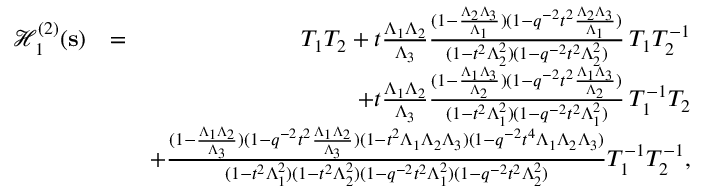<formula> <loc_0><loc_0><loc_500><loc_500>\begin{array} { r l r } { \mathcal { H } _ { 1 } ^ { ( 2 ) } ( \mathbf s ) } & { = } & { T _ { 1 } T _ { 2 } + t \frac { \Lambda _ { 1 } \Lambda _ { 2 } } { \Lambda _ { 3 } } \frac { ( 1 - \frac { \Lambda _ { 2 } \Lambda _ { 3 } } { \Lambda _ { 1 } } ) ( 1 - q ^ { - 2 } t ^ { 2 } \frac { \Lambda _ { 2 } \Lambda _ { 3 } } { \Lambda _ { 1 } } ) } { ( 1 - t ^ { 2 } \Lambda _ { 2 } ^ { 2 } ) ( 1 - q ^ { - 2 } t ^ { 2 } \Lambda _ { 2 } ^ { 2 } ) } \, T _ { 1 } T _ { 2 } ^ { - 1 } } \\ & { + t \frac { \Lambda _ { 1 } \Lambda _ { 2 } } { \Lambda _ { 3 } } \frac { ( 1 - \frac { \Lambda _ { 1 } \Lambda _ { 3 } } { \Lambda _ { 2 } } ) ( 1 - q ^ { - 2 } t ^ { 2 } \frac { \Lambda _ { 1 } \Lambda _ { 3 } } { \Lambda _ { 2 } } ) } { ( 1 - t ^ { 2 } \Lambda _ { 1 } ^ { 2 } ) ( 1 - q ^ { - 2 } t ^ { 2 } \Lambda _ { 1 } ^ { 2 } ) } \, T _ { 1 } ^ { - 1 } T _ { 2 } } \\ & { + \frac { ( 1 - \frac { \Lambda _ { 1 } \Lambda _ { 2 } } { \Lambda _ { 3 } } ) ( 1 - q ^ { - 2 } t ^ { 2 } \frac { \Lambda _ { 1 } \Lambda _ { 2 } } { \Lambda _ { 3 } } ) ( 1 - t ^ { 2 } \Lambda _ { 1 } \Lambda _ { 2 } \Lambda _ { 3 } ) ( 1 - q ^ { - 2 } t ^ { 4 } \Lambda _ { 1 } \Lambda _ { 2 } \Lambda _ { 3 } ) } { ( 1 - t ^ { 2 } \Lambda _ { 1 } ^ { 2 } ) ( 1 - t ^ { 2 } \Lambda _ { 2 } ^ { 2 } ) ( 1 - q ^ { - 2 } t ^ { 2 } \Lambda _ { 1 } ^ { 2 } ) ( 1 - q ^ { - 2 } t ^ { 2 } \Lambda _ { 2 } ^ { 2 } ) } T _ { 1 } ^ { - 1 } T _ { 2 } ^ { - 1 } , } \end{array}</formula> 